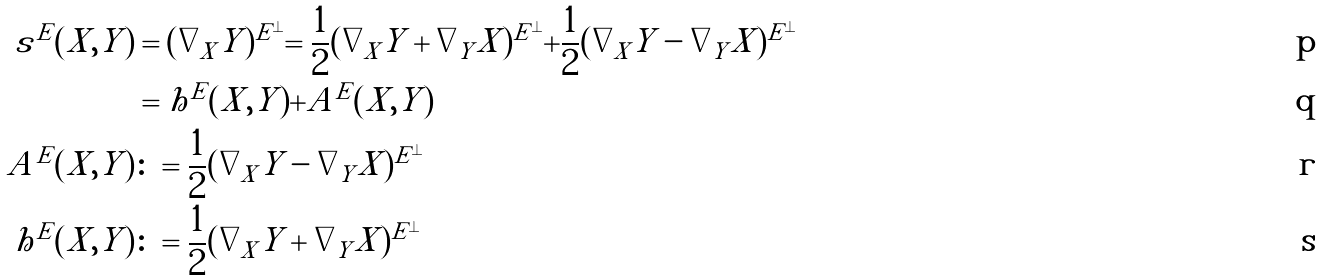<formula> <loc_0><loc_0><loc_500><loc_500>s ^ { E } ( X , Y ) & = ( \nabla _ { X } Y ) ^ { E ^ { \perp } } = \frac { 1 } { 2 } ( \nabla _ { X } Y + \nabla _ { Y } X ) ^ { E ^ { \perp } } + \frac { 1 } { 2 } ( \nabla _ { X } Y - \nabla _ { Y } X ) ^ { E ^ { \perp } } \\ & = h ^ { E } ( X , Y ) + A ^ { E } ( X , Y ) \\ A ^ { E } ( X , Y ) & \colon = \frac { 1 } { 2 } ( \nabla _ { X } Y - \nabla _ { Y } X ) ^ { E ^ { \perp } } \\ h ^ { E } ( X , Y ) & \colon = \frac { 1 } { 2 } ( \nabla _ { X } Y + \nabla _ { Y } X ) ^ { E ^ { \perp } }</formula> 